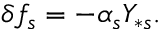<formula> <loc_0><loc_0><loc_500><loc_500>\delta f _ { s } = - \alpha _ { s } Y _ { \ast s } .</formula> 